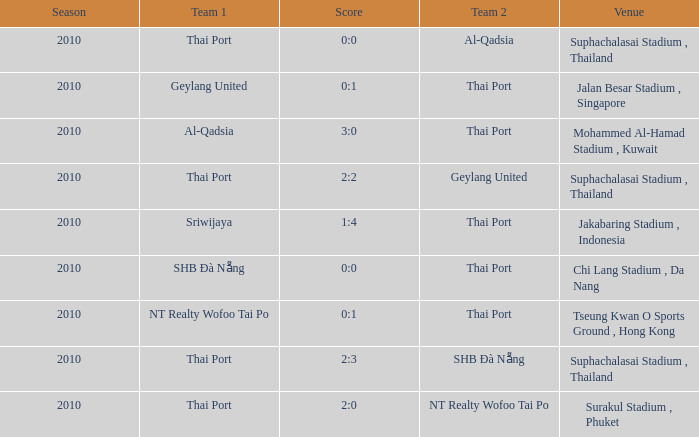What was the score for the game in which Al-Qadsia was Team 2? 0:0. 